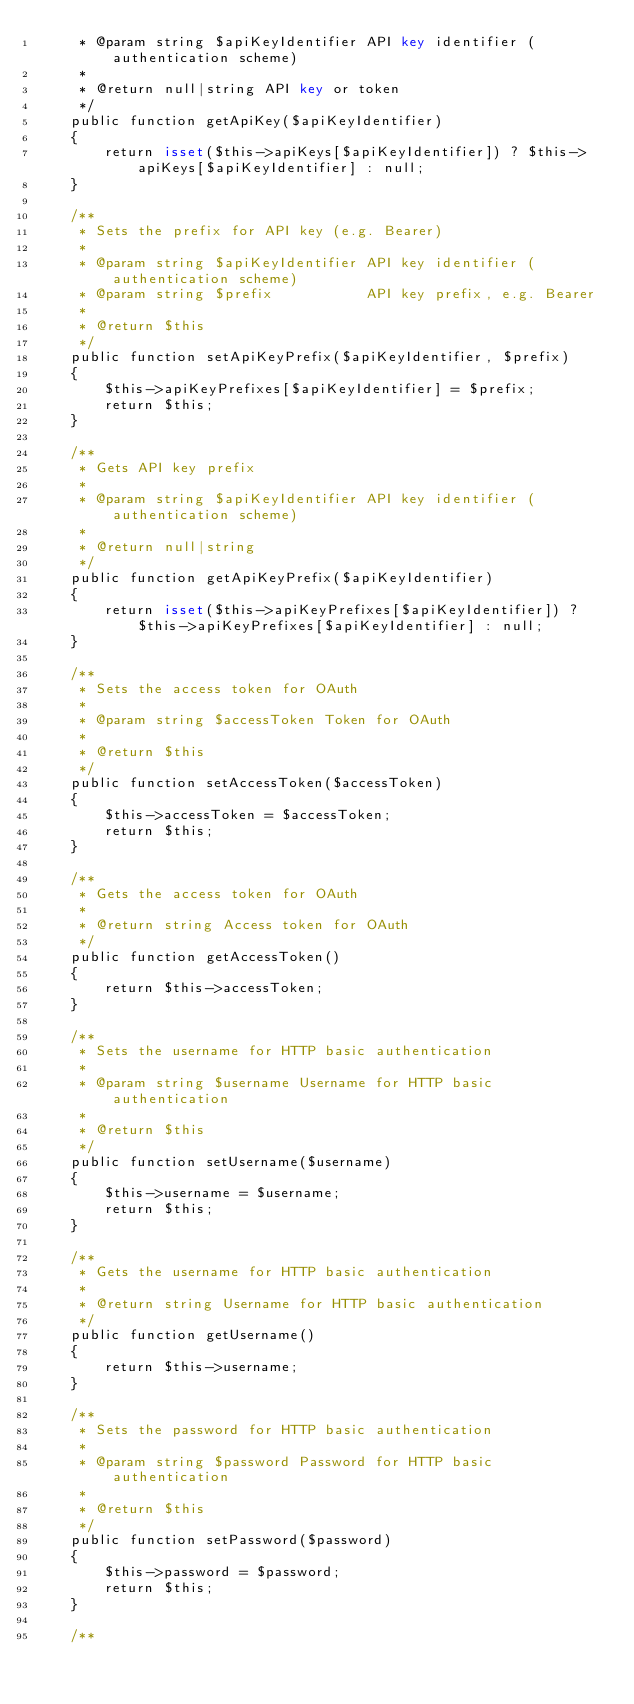<code> <loc_0><loc_0><loc_500><loc_500><_PHP_>     * @param string $apiKeyIdentifier API key identifier (authentication scheme)
     *
     * @return null|string API key or token
     */
    public function getApiKey($apiKeyIdentifier)
    {
        return isset($this->apiKeys[$apiKeyIdentifier]) ? $this->apiKeys[$apiKeyIdentifier] : null;
    }

    /**
     * Sets the prefix for API key (e.g. Bearer)
     *
     * @param string $apiKeyIdentifier API key identifier (authentication scheme)
     * @param string $prefix           API key prefix, e.g. Bearer
     *
     * @return $this
     */
    public function setApiKeyPrefix($apiKeyIdentifier, $prefix)
    {
        $this->apiKeyPrefixes[$apiKeyIdentifier] = $prefix;
        return $this;
    }

    /**
     * Gets API key prefix
     *
     * @param string $apiKeyIdentifier API key identifier (authentication scheme)
     *
     * @return null|string
     */
    public function getApiKeyPrefix($apiKeyIdentifier)
    {
        return isset($this->apiKeyPrefixes[$apiKeyIdentifier]) ? $this->apiKeyPrefixes[$apiKeyIdentifier] : null;
    }

    /**
     * Sets the access token for OAuth
     *
     * @param string $accessToken Token for OAuth
     *
     * @return $this
     */
    public function setAccessToken($accessToken)
    {
        $this->accessToken = $accessToken;
        return $this;
    }

    /**
     * Gets the access token for OAuth
     *
     * @return string Access token for OAuth
     */
    public function getAccessToken()
    {
        return $this->accessToken;
    }

    /**
     * Sets the username for HTTP basic authentication
     *
     * @param string $username Username for HTTP basic authentication
     *
     * @return $this
     */
    public function setUsername($username)
    {
        $this->username = $username;
        return $this;
    }

    /**
     * Gets the username for HTTP basic authentication
     *
     * @return string Username for HTTP basic authentication
     */
    public function getUsername()
    {
        return $this->username;
    }

    /**
     * Sets the password for HTTP basic authentication
     *
     * @param string $password Password for HTTP basic authentication
     *
     * @return $this
     */
    public function setPassword($password)
    {
        $this->password = $password;
        return $this;
    }

    /**</code> 